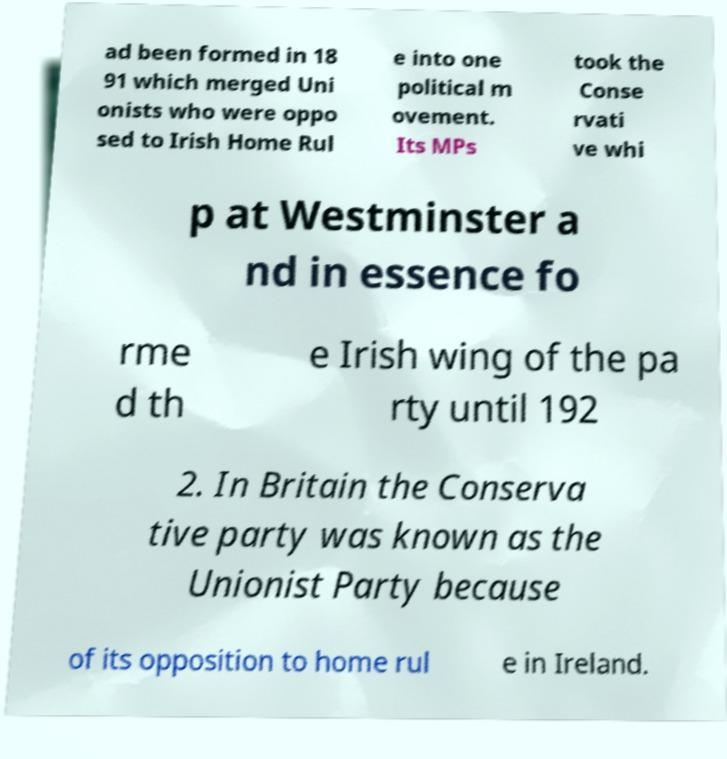Please identify and transcribe the text found in this image. ad been formed in 18 91 which merged Uni onists who were oppo sed to Irish Home Rul e into one political m ovement. Its MPs took the Conse rvati ve whi p at Westminster a nd in essence fo rme d th e Irish wing of the pa rty until 192 2. In Britain the Conserva tive party was known as the Unionist Party because of its opposition to home rul e in Ireland. 